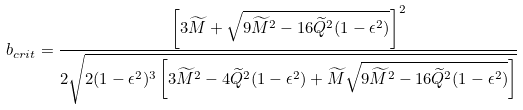<formula> <loc_0><loc_0><loc_500><loc_500>b _ { c r i t } = \frac { \left [ 3 \widetilde { M } + \sqrt { 9 \widetilde { M } ^ { 2 } - 1 6 \widetilde { Q } ^ { 2 } ( 1 - \epsilon ^ { 2 } ) } \right ] ^ { 2 } } { 2 \sqrt { 2 ( 1 - \epsilon ^ { 2 } ) ^ { 3 } \left [ 3 \widetilde { M } ^ { 2 } - 4 \widetilde { Q } ^ { 2 } ( 1 - \epsilon ^ { 2 } ) + \widetilde { M } \sqrt { 9 \widetilde { M } ^ { 2 } - 1 6 \widetilde { Q } ^ { 2 } ( 1 - \epsilon ^ { 2 } ) } \right ] } }</formula> 